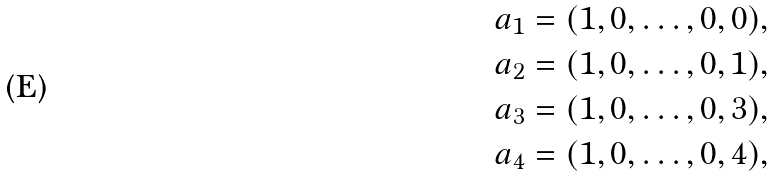<formula> <loc_0><loc_0><loc_500><loc_500>a _ { 1 } & = ( 1 , 0 , \dots , 0 , 0 ) , \\ a _ { 2 } & = ( 1 , 0 , \dots , 0 , 1 ) , \\ a _ { 3 } & = ( 1 , 0 , \dots , 0 , 3 ) , \\ a _ { 4 } & = ( 1 , 0 , \dots , 0 , 4 ) ,</formula> 